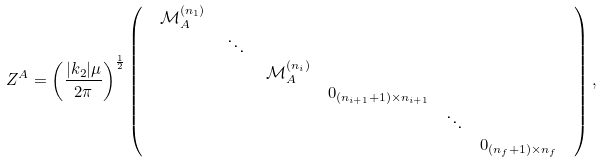<formula> <loc_0><loc_0><loc_500><loc_500>Z ^ { A } & = \left ( \frac { | k _ { 2 } | \mu } { 2 \pi } \right ) ^ { \frac { 1 } { 2 } } \left ( \begin{array} { c } \begin{array} { c c c c c c } \mathcal { M } _ { A } ^ { ( n _ { 1 } ) } \, & & & & & \\ & \, \ddots \, & & & & \\ & & \, \mathcal { M } _ { A } ^ { ( n _ { i } ) } & & & \\ & & & { 0 } _ { ( n _ { i + 1 } + 1 ) \times n _ { i + 1 } } & & \\ & & & & \ddots & \\ & & & & & { 0 } _ { ( n _ { f } + 1 ) \times n _ { f } } \end{array} \\ \end{array} \right ) ,</formula> 